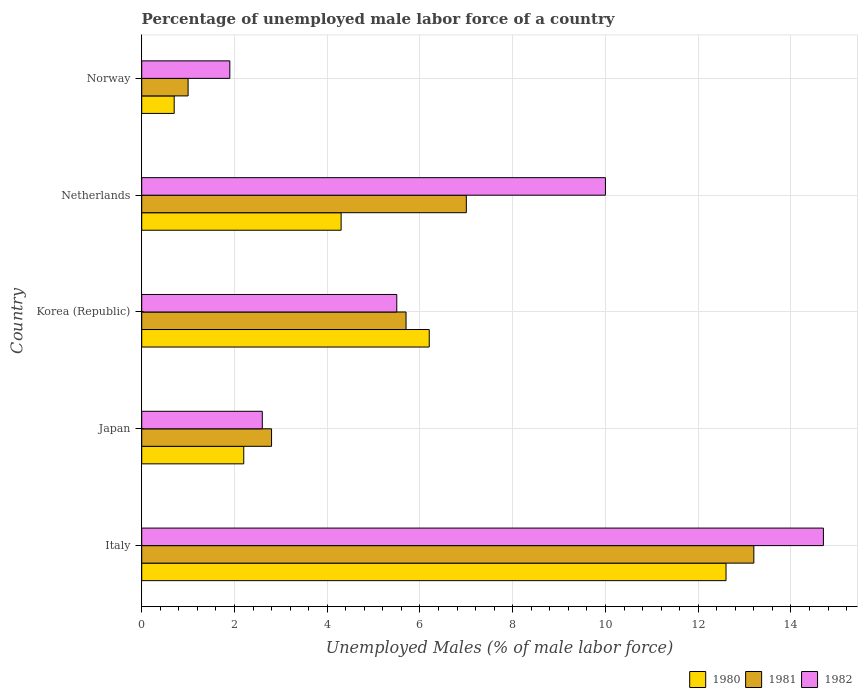How many groups of bars are there?
Provide a short and direct response. 5. Are the number of bars per tick equal to the number of legend labels?
Ensure brevity in your answer.  Yes. Are the number of bars on each tick of the Y-axis equal?
Offer a very short reply. Yes. How many bars are there on the 1st tick from the top?
Offer a terse response. 3. How many bars are there on the 1st tick from the bottom?
Offer a very short reply. 3. In how many cases, is the number of bars for a given country not equal to the number of legend labels?
Offer a very short reply. 0. What is the percentage of unemployed male labor force in 1981 in Japan?
Provide a short and direct response. 2.8. Across all countries, what is the maximum percentage of unemployed male labor force in 1981?
Offer a very short reply. 13.2. Across all countries, what is the minimum percentage of unemployed male labor force in 1981?
Your response must be concise. 1. In which country was the percentage of unemployed male labor force in 1982 maximum?
Make the answer very short. Italy. What is the total percentage of unemployed male labor force in 1982 in the graph?
Your response must be concise. 34.7. What is the difference between the percentage of unemployed male labor force in 1981 in Japan and that in Korea (Republic)?
Offer a terse response. -2.9. What is the difference between the percentage of unemployed male labor force in 1981 in Italy and the percentage of unemployed male labor force in 1980 in Japan?
Offer a very short reply. 11. What is the average percentage of unemployed male labor force in 1981 per country?
Provide a short and direct response. 5.94. What is the difference between the percentage of unemployed male labor force in 1982 and percentage of unemployed male labor force in 1981 in Japan?
Your answer should be very brief. -0.2. In how many countries, is the percentage of unemployed male labor force in 1982 greater than 6.8 %?
Ensure brevity in your answer.  2. What is the ratio of the percentage of unemployed male labor force in 1982 in Italy to that in Netherlands?
Provide a short and direct response. 1.47. Is the percentage of unemployed male labor force in 1980 in Italy less than that in Netherlands?
Keep it short and to the point. No. Is the difference between the percentage of unemployed male labor force in 1982 in Korea (Republic) and Norway greater than the difference between the percentage of unemployed male labor force in 1981 in Korea (Republic) and Norway?
Give a very brief answer. No. What is the difference between the highest and the second highest percentage of unemployed male labor force in 1982?
Provide a succinct answer. 4.7. What is the difference between the highest and the lowest percentage of unemployed male labor force in 1982?
Keep it short and to the point. 12.8. In how many countries, is the percentage of unemployed male labor force in 1981 greater than the average percentage of unemployed male labor force in 1981 taken over all countries?
Offer a very short reply. 2. Is the sum of the percentage of unemployed male labor force in 1980 in Netherlands and Norway greater than the maximum percentage of unemployed male labor force in 1981 across all countries?
Your answer should be compact. No. What does the 2nd bar from the top in Italy represents?
Your answer should be very brief. 1981. Is it the case that in every country, the sum of the percentage of unemployed male labor force in 1980 and percentage of unemployed male labor force in 1982 is greater than the percentage of unemployed male labor force in 1981?
Offer a very short reply. Yes. How many bars are there?
Your answer should be very brief. 15. What is the difference between two consecutive major ticks on the X-axis?
Keep it short and to the point. 2. How are the legend labels stacked?
Ensure brevity in your answer.  Horizontal. What is the title of the graph?
Your response must be concise. Percentage of unemployed male labor force of a country. Does "1964" appear as one of the legend labels in the graph?
Make the answer very short. No. What is the label or title of the X-axis?
Provide a succinct answer. Unemployed Males (% of male labor force). What is the Unemployed Males (% of male labor force) in 1980 in Italy?
Provide a succinct answer. 12.6. What is the Unemployed Males (% of male labor force) of 1981 in Italy?
Give a very brief answer. 13.2. What is the Unemployed Males (% of male labor force) in 1982 in Italy?
Provide a short and direct response. 14.7. What is the Unemployed Males (% of male labor force) in 1980 in Japan?
Make the answer very short. 2.2. What is the Unemployed Males (% of male labor force) of 1981 in Japan?
Provide a short and direct response. 2.8. What is the Unemployed Males (% of male labor force) of 1982 in Japan?
Provide a short and direct response. 2.6. What is the Unemployed Males (% of male labor force) in 1980 in Korea (Republic)?
Keep it short and to the point. 6.2. What is the Unemployed Males (% of male labor force) in 1981 in Korea (Republic)?
Ensure brevity in your answer.  5.7. What is the Unemployed Males (% of male labor force) in 1982 in Korea (Republic)?
Your response must be concise. 5.5. What is the Unemployed Males (% of male labor force) in 1980 in Netherlands?
Offer a terse response. 4.3. What is the Unemployed Males (% of male labor force) in 1981 in Netherlands?
Ensure brevity in your answer.  7. What is the Unemployed Males (% of male labor force) in 1982 in Netherlands?
Provide a short and direct response. 10. What is the Unemployed Males (% of male labor force) of 1980 in Norway?
Give a very brief answer. 0.7. What is the Unemployed Males (% of male labor force) of 1981 in Norway?
Keep it short and to the point. 1. What is the Unemployed Males (% of male labor force) in 1982 in Norway?
Your answer should be very brief. 1.9. Across all countries, what is the maximum Unemployed Males (% of male labor force) of 1980?
Your answer should be very brief. 12.6. Across all countries, what is the maximum Unemployed Males (% of male labor force) in 1981?
Your answer should be compact. 13.2. Across all countries, what is the maximum Unemployed Males (% of male labor force) of 1982?
Provide a short and direct response. 14.7. Across all countries, what is the minimum Unemployed Males (% of male labor force) in 1980?
Provide a short and direct response. 0.7. Across all countries, what is the minimum Unemployed Males (% of male labor force) in 1981?
Offer a terse response. 1. Across all countries, what is the minimum Unemployed Males (% of male labor force) in 1982?
Give a very brief answer. 1.9. What is the total Unemployed Males (% of male labor force) in 1981 in the graph?
Your response must be concise. 29.7. What is the total Unemployed Males (% of male labor force) in 1982 in the graph?
Make the answer very short. 34.7. What is the difference between the Unemployed Males (% of male labor force) of 1980 in Italy and that in Japan?
Make the answer very short. 10.4. What is the difference between the Unemployed Males (% of male labor force) of 1981 in Italy and that in Japan?
Offer a very short reply. 10.4. What is the difference between the Unemployed Males (% of male labor force) in 1980 in Italy and that in Netherlands?
Provide a short and direct response. 8.3. What is the difference between the Unemployed Males (% of male labor force) in 1981 in Italy and that in Netherlands?
Provide a short and direct response. 6.2. What is the difference between the Unemployed Males (% of male labor force) of 1982 in Italy and that in Netherlands?
Your response must be concise. 4.7. What is the difference between the Unemployed Males (% of male labor force) of 1982 in Italy and that in Norway?
Offer a terse response. 12.8. What is the difference between the Unemployed Males (% of male labor force) in 1982 in Japan and that in Korea (Republic)?
Offer a very short reply. -2.9. What is the difference between the Unemployed Males (% of male labor force) in 1980 in Japan and that in Netherlands?
Give a very brief answer. -2.1. What is the difference between the Unemployed Males (% of male labor force) of 1981 in Japan and that in Norway?
Your answer should be compact. 1.8. What is the difference between the Unemployed Males (% of male labor force) of 1982 in Japan and that in Norway?
Provide a succinct answer. 0.7. What is the difference between the Unemployed Males (% of male labor force) in 1980 in Korea (Republic) and that in Netherlands?
Provide a succinct answer. 1.9. What is the difference between the Unemployed Males (% of male labor force) of 1981 in Korea (Republic) and that in Netherlands?
Provide a short and direct response. -1.3. What is the difference between the Unemployed Males (% of male labor force) in 1982 in Korea (Republic) and that in Netherlands?
Provide a short and direct response. -4.5. What is the difference between the Unemployed Males (% of male labor force) in 1981 in Korea (Republic) and that in Norway?
Offer a very short reply. 4.7. What is the difference between the Unemployed Males (% of male labor force) in 1982 in Korea (Republic) and that in Norway?
Offer a terse response. 3.6. What is the difference between the Unemployed Males (% of male labor force) in 1980 in Netherlands and that in Norway?
Provide a succinct answer. 3.6. What is the difference between the Unemployed Males (% of male labor force) of 1981 in Netherlands and that in Norway?
Ensure brevity in your answer.  6. What is the difference between the Unemployed Males (% of male labor force) in 1980 in Italy and the Unemployed Males (% of male labor force) in 1981 in Japan?
Your answer should be very brief. 9.8. What is the difference between the Unemployed Males (% of male labor force) in 1980 in Italy and the Unemployed Males (% of male labor force) in 1982 in Japan?
Provide a short and direct response. 10. What is the difference between the Unemployed Males (% of male labor force) of 1981 in Italy and the Unemployed Males (% of male labor force) of 1982 in Japan?
Ensure brevity in your answer.  10.6. What is the difference between the Unemployed Males (% of male labor force) of 1980 in Italy and the Unemployed Males (% of male labor force) of 1982 in Korea (Republic)?
Provide a short and direct response. 7.1. What is the difference between the Unemployed Males (% of male labor force) in 1980 in Italy and the Unemployed Males (% of male labor force) in 1981 in Netherlands?
Make the answer very short. 5.6. What is the difference between the Unemployed Males (% of male labor force) of 1980 in Italy and the Unemployed Males (% of male labor force) of 1981 in Norway?
Provide a short and direct response. 11.6. What is the difference between the Unemployed Males (% of male labor force) of 1980 in Italy and the Unemployed Males (% of male labor force) of 1982 in Norway?
Give a very brief answer. 10.7. What is the difference between the Unemployed Males (% of male labor force) in 1980 in Japan and the Unemployed Males (% of male labor force) in 1981 in Korea (Republic)?
Provide a succinct answer. -3.5. What is the difference between the Unemployed Males (% of male labor force) of 1981 in Japan and the Unemployed Males (% of male labor force) of 1982 in Korea (Republic)?
Your response must be concise. -2.7. What is the difference between the Unemployed Males (% of male labor force) in 1980 in Japan and the Unemployed Males (% of male labor force) in 1981 in Netherlands?
Your answer should be compact. -4.8. What is the difference between the Unemployed Males (% of male labor force) in 1981 in Japan and the Unemployed Males (% of male labor force) in 1982 in Netherlands?
Your answer should be very brief. -7.2. What is the difference between the Unemployed Males (% of male labor force) in 1980 in Korea (Republic) and the Unemployed Males (% of male labor force) in 1982 in Netherlands?
Keep it short and to the point. -3.8. What is the difference between the Unemployed Males (% of male labor force) in 1981 in Korea (Republic) and the Unemployed Males (% of male labor force) in 1982 in Netherlands?
Keep it short and to the point. -4.3. What is the difference between the Unemployed Males (% of male labor force) in 1980 in Korea (Republic) and the Unemployed Males (% of male labor force) in 1981 in Norway?
Keep it short and to the point. 5.2. What is the difference between the Unemployed Males (% of male labor force) of 1980 in Korea (Republic) and the Unemployed Males (% of male labor force) of 1982 in Norway?
Keep it short and to the point. 4.3. What is the difference between the Unemployed Males (% of male labor force) in 1981 in Korea (Republic) and the Unemployed Males (% of male labor force) in 1982 in Norway?
Your answer should be compact. 3.8. What is the difference between the Unemployed Males (% of male labor force) in 1980 in Netherlands and the Unemployed Males (% of male labor force) in 1981 in Norway?
Your answer should be compact. 3.3. What is the difference between the Unemployed Males (% of male labor force) in 1980 in Netherlands and the Unemployed Males (% of male labor force) in 1982 in Norway?
Your answer should be very brief. 2.4. What is the difference between the Unemployed Males (% of male labor force) of 1981 in Netherlands and the Unemployed Males (% of male labor force) of 1982 in Norway?
Provide a short and direct response. 5.1. What is the average Unemployed Males (% of male labor force) of 1981 per country?
Ensure brevity in your answer.  5.94. What is the average Unemployed Males (% of male labor force) in 1982 per country?
Keep it short and to the point. 6.94. What is the difference between the Unemployed Males (% of male labor force) of 1980 and Unemployed Males (% of male labor force) of 1981 in Italy?
Offer a very short reply. -0.6. What is the difference between the Unemployed Males (% of male labor force) in 1980 and Unemployed Males (% of male labor force) in 1982 in Italy?
Offer a very short reply. -2.1. What is the difference between the Unemployed Males (% of male labor force) in 1981 and Unemployed Males (% of male labor force) in 1982 in Japan?
Your response must be concise. 0.2. What is the difference between the Unemployed Males (% of male labor force) of 1980 and Unemployed Males (% of male labor force) of 1982 in Korea (Republic)?
Keep it short and to the point. 0.7. What is the difference between the Unemployed Males (% of male labor force) in 1981 and Unemployed Males (% of male labor force) in 1982 in Korea (Republic)?
Keep it short and to the point. 0.2. What is the difference between the Unemployed Males (% of male labor force) in 1980 and Unemployed Males (% of male labor force) in 1981 in Netherlands?
Provide a succinct answer. -2.7. What is the difference between the Unemployed Males (% of male labor force) of 1981 and Unemployed Males (% of male labor force) of 1982 in Netherlands?
Ensure brevity in your answer.  -3. What is the difference between the Unemployed Males (% of male labor force) of 1980 and Unemployed Males (% of male labor force) of 1981 in Norway?
Your answer should be compact. -0.3. What is the ratio of the Unemployed Males (% of male labor force) in 1980 in Italy to that in Japan?
Your response must be concise. 5.73. What is the ratio of the Unemployed Males (% of male labor force) in 1981 in Italy to that in Japan?
Keep it short and to the point. 4.71. What is the ratio of the Unemployed Males (% of male labor force) in 1982 in Italy to that in Japan?
Your answer should be compact. 5.65. What is the ratio of the Unemployed Males (% of male labor force) of 1980 in Italy to that in Korea (Republic)?
Keep it short and to the point. 2.03. What is the ratio of the Unemployed Males (% of male labor force) in 1981 in Italy to that in Korea (Republic)?
Make the answer very short. 2.32. What is the ratio of the Unemployed Males (% of male labor force) of 1982 in Italy to that in Korea (Republic)?
Keep it short and to the point. 2.67. What is the ratio of the Unemployed Males (% of male labor force) of 1980 in Italy to that in Netherlands?
Provide a succinct answer. 2.93. What is the ratio of the Unemployed Males (% of male labor force) in 1981 in Italy to that in Netherlands?
Ensure brevity in your answer.  1.89. What is the ratio of the Unemployed Males (% of male labor force) in 1982 in Italy to that in Netherlands?
Give a very brief answer. 1.47. What is the ratio of the Unemployed Males (% of male labor force) of 1980 in Italy to that in Norway?
Your answer should be very brief. 18. What is the ratio of the Unemployed Males (% of male labor force) in 1982 in Italy to that in Norway?
Your answer should be compact. 7.74. What is the ratio of the Unemployed Males (% of male labor force) of 1980 in Japan to that in Korea (Republic)?
Your response must be concise. 0.35. What is the ratio of the Unemployed Males (% of male labor force) in 1981 in Japan to that in Korea (Republic)?
Your response must be concise. 0.49. What is the ratio of the Unemployed Males (% of male labor force) of 1982 in Japan to that in Korea (Republic)?
Your response must be concise. 0.47. What is the ratio of the Unemployed Males (% of male labor force) of 1980 in Japan to that in Netherlands?
Offer a very short reply. 0.51. What is the ratio of the Unemployed Males (% of male labor force) of 1981 in Japan to that in Netherlands?
Your answer should be very brief. 0.4. What is the ratio of the Unemployed Males (% of male labor force) in 1982 in Japan to that in Netherlands?
Provide a short and direct response. 0.26. What is the ratio of the Unemployed Males (% of male labor force) of 1980 in Japan to that in Norway?
Your answer should be very brief. 3.14. What is the ratio of the Unemployed Males (% of male labor force) of 1982 in Japan to that in Norway?
Offer a very short reply. 1.37. What is the ratio of the Unemployed Males (% of male labor force) of 1980 in Korea (Republic) to that in Netherlands?
Your answer should be compact. 1.44. What is the ratio of the Unemployed Males (% of male labor force) of 1981 in Korea (Republic) to that in Netherlands?
Make the answer very short. 0.81. What is the ratio of the Unemployed Males (% of male labor force) of 1982 in Korea (Republic) to that in Netherlands?
Offer a terse response. 0.55. What is the ratio of the Unemployed Males (% of male labor force) in 1980 in Korea (Republic) to that in Norway?
Offer a terse response. 8.86. What is the ratio of the Unemployed Males (% of male labor force) of 1982 in Korea (Republic) to that in Norway?
Make the answer very short. 2.89. What is the ratio of the Unemployed Males (% of male labor force) in 1980 in Netherlands to that in Norway?
Make the answer very short. 6.14. What is the ratio of the Unemployed Males (% of male labor force) in 1982 in Netherlands to that in Norway?
Keep it short and to the point. 5.26. What is the difference between the highest and the second highest Unemployed Males (% of male labor force) of 1982?
Give a very brief answer. 4.7. What is the difference between the highest and the lowest Unemployed Males (% of male labor force) in 1981?
Offer a very short reply. 12.2. What is the difference between the highest and the lowest Unemployed Males (% of male labor force) in 1982?
Offer a terse response. 12.8. 